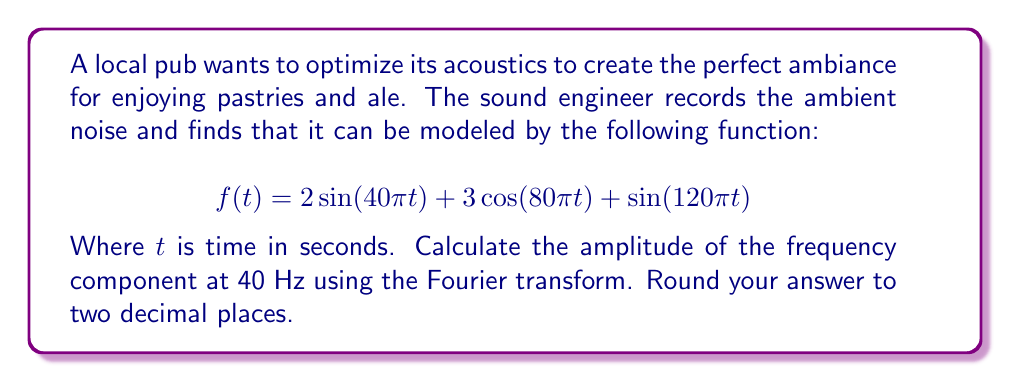Give your solution to this math problem. To solve this problem, we'll use the Fourier transform to analyze the frequency components of the given function. The Fourier transform of a continuous-time signal $f(t)$ is given by:

$$F(\omega) = \int_{-\infty}^{\infty} f(t) e^{-j\omega t} dt$$

Where $\omega = 2\pi f$ and $f$ is the frequency in Hz.

Let's break down the given function:

1. $2\sin(40\pi t)$: This component has a frequency of 20 Hz
2. $3\cos(80\pi t)$: This component has a frequency of 40 Hz
3. $\sin(120\pi t)$: This component has a frequency of 60 Hz

We're interested in the 40 Hz component, which corresponds to the cosine term.

For a cosine function of the form $A\cos(\omega t)$, its Fourier transform is:

$$F(\omega) = \pi A[\delta(\omega - \omega_0) + \delta(\omega + \omega_0)]$$

Where $\delta$ is the Dirac delta function and $\omega_0$ is the angular frequency of the cosine.

In our case, $A = 3$ and $\omega_0 = 80\pi$ rad/s (corresponding to 40 Hz).

The amplitude of the frequency component at 40 Hz is half of the coefficient $A$, which is $3/2 = 1.5$.
Answer: 1.50 